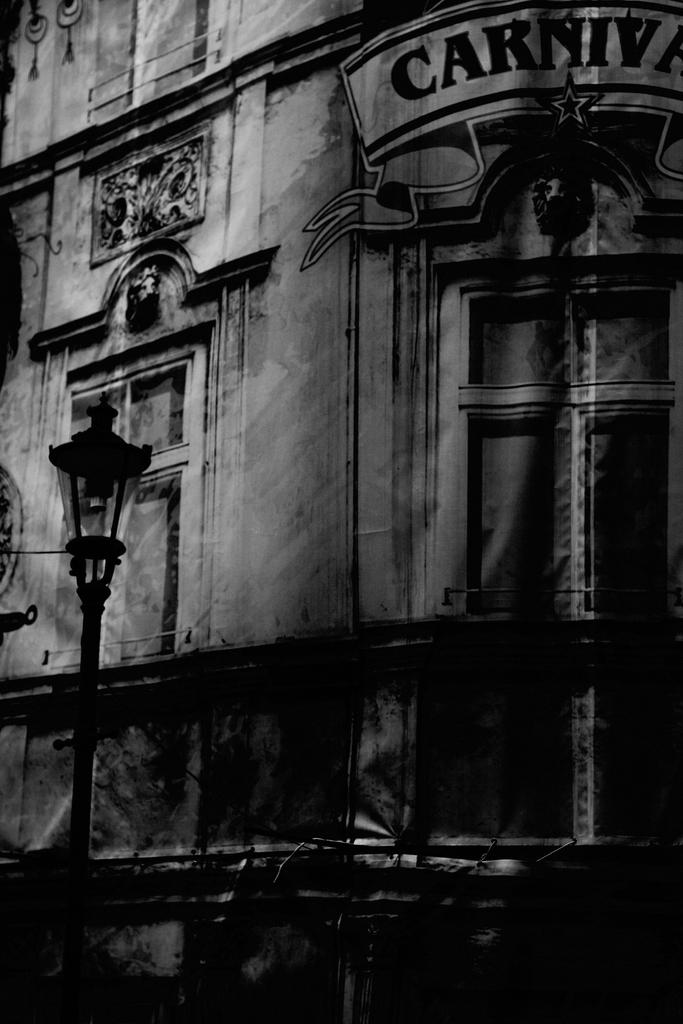What type of structure is present in the image? There is a building in the image. What other object can be seen near the building? There is a light pole in the image. Can you describe any specific features of the building? There is a door visible in the background of the image. What is the color scheme of the image? The image is in black and white. What type of food is being served on the clock in the image? There is no clock or food present in the image. Is the crook trying to break into the building in the image? There is no crook or indication of any criminal activity in the image. 